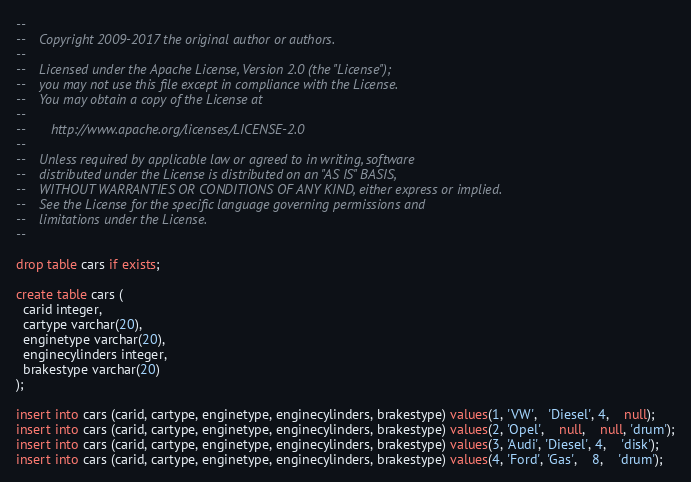Convert code to text. <code><loc_0><loc_0><loc_500><loc_500><_SQL_>--
--    Copyright 2009-2017 the original author or authors.
--
--    Licensed under the Apache License, Version 2.0 (the "License");
--    you may not use this file except in compliance with the License.
--    You may obtain a copy of the License at
--
--       http://www.apache.org/licenses/LICENSE-2.0
--
--    Unless required by applicable law or agreed to in writing, software
--    distributed under the License is distributed on an "AS IS" BASIS,
--    WITHOUT WARRANTIES OR CONDITIONS OF ANY KIND, either express or implied.
--    See the License for the specific language governing permissions and
--    limitations under the License.
--

drop table cars if exists;

create table cars (
  carid integer,
  cartype varchar(20),
  enginetype varchar(20),
  enginecylinders integer,
  brakestype varchar(20)
);

insert into cars (carid, cartype, enginetype, enginecylinders, brakestype) values(1, 'VW',   'Diesel', 4,    null);
insert into cars (carid, cartype, enginetype, enginecylinders, brakestype) values(2, 'Opel',    null,    null, 'drum');
insert into cars (carid, cartype, enginetype, enginecylinders, brakestype) values(3, 'Audi', 'Diesel', 4,    'disk');
insert into cars (carid, cartype, enginetype, enginecylinders, brakestype) values(4, 'Ford', 'Gas',    8,    'drum');
</code> 